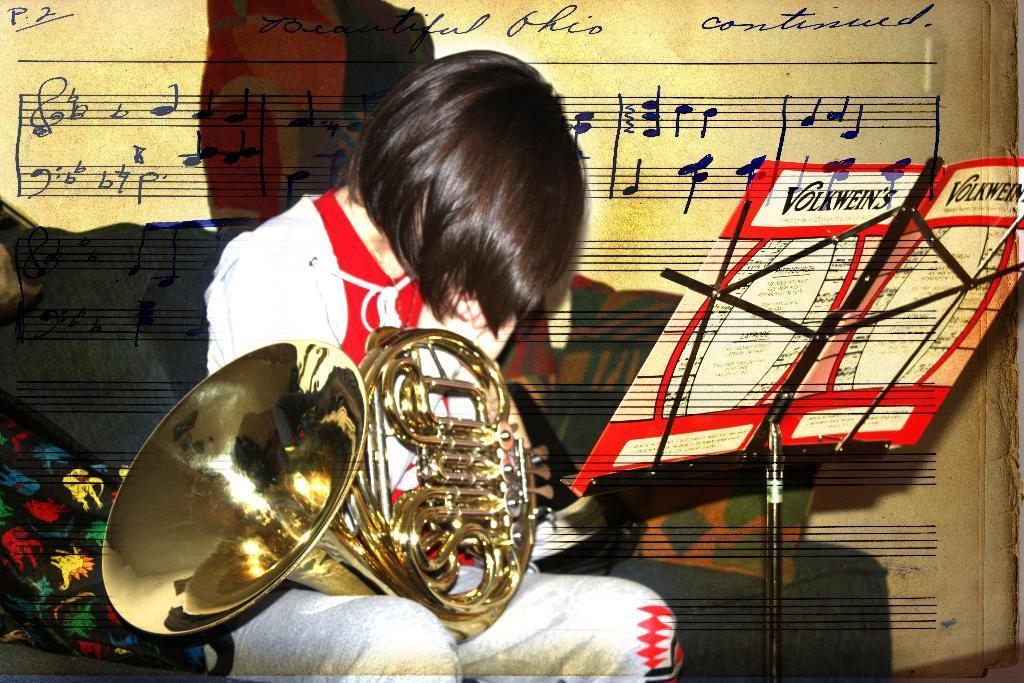In one or two sentences, can you explain what this image depicts? In the center of this picture we can see a person sitting on a couch and holding a french horn. On the right we can see the text on the papers and the papers are attached to the metal stand. In the background we can see the text and some pictures and we can see the cushions and this picture seems to be an edited image. 